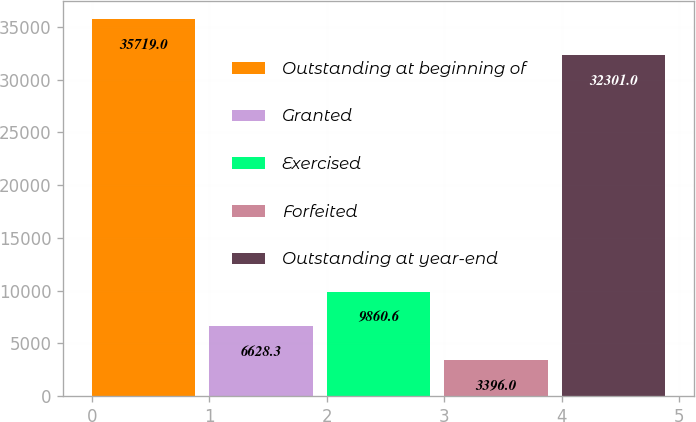Convert chart to OTSL. <chart><loc_0><loc_0><loc_500><loc_500><bar_chart><fcel>Outstanding at beginning of<fcel>Granted<fcel>Exercised<fcel>Forfeited<fcel>Outstanding at year-end<nl><fcel>35719<fcel>6628.3<fcel>9860.6<fcel>3396<fcel>32301<nl></chart> 